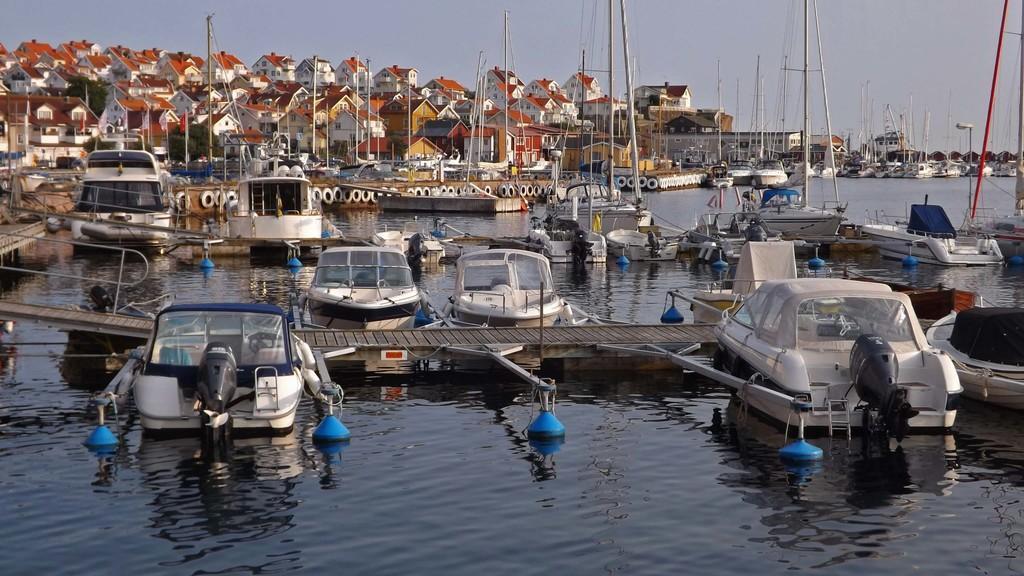Can you describe this image briefly? In this image we can see the boats, poles, wooden bridgewater, houses, at the top we can see the sky. 